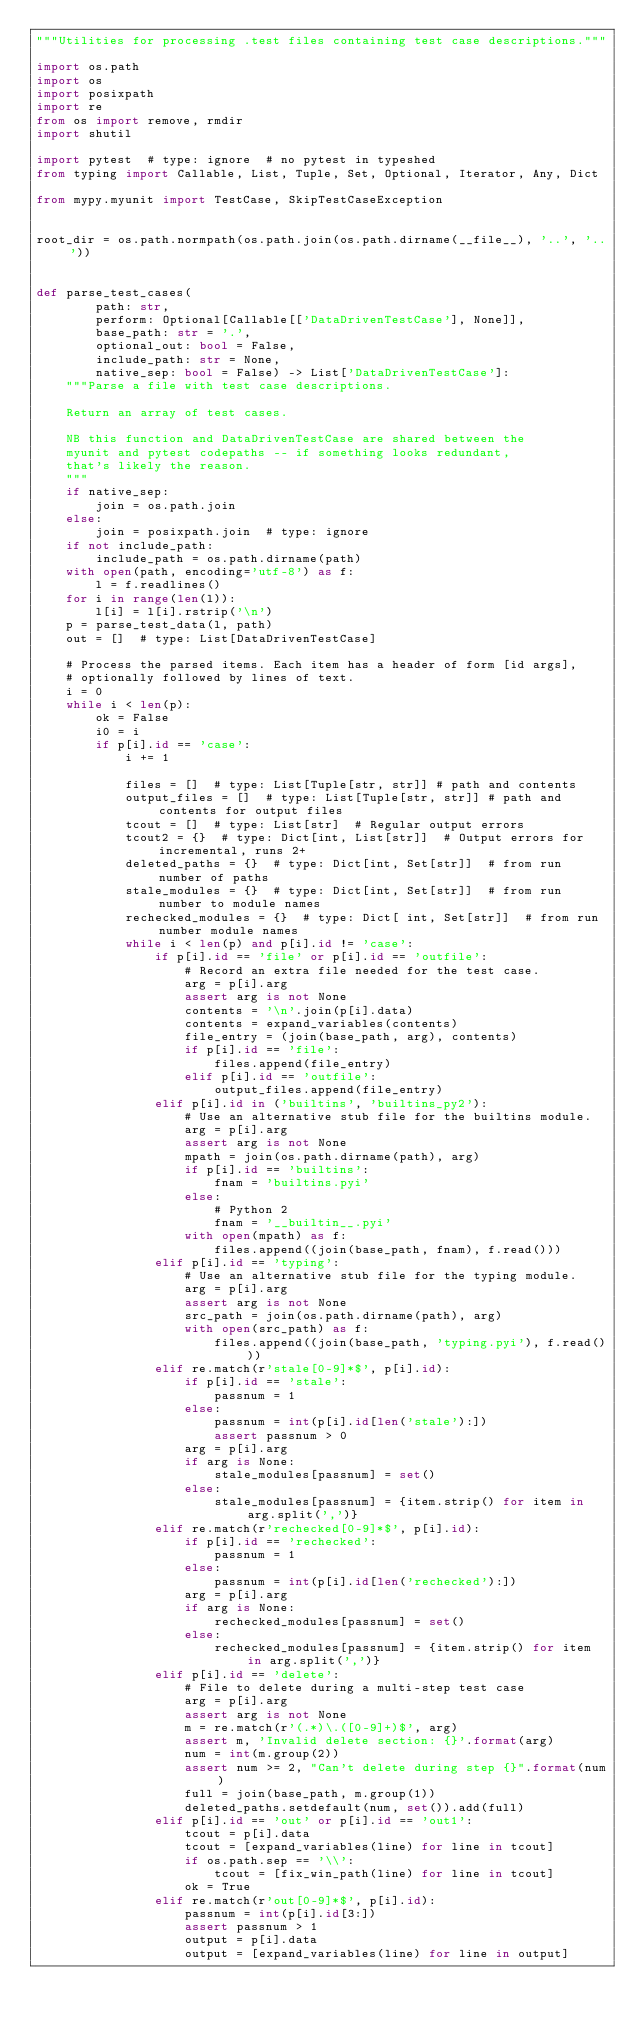Convert code to text. <code><loc_0><loc_0><loc_500><loc_500><_Python_>"""Utilities for processing .test files containing test case descriptions."""

import os.path
import os
import posixpath
import re
from os import remove, rmdir
import shutil

import pytest  # type: ignore  # no pytest in typeshed
from typing import Callable, List, Tuple, Set, Optional, Iterator, Any, Dict

from mypy.myunit import TestCase, SkipTestCaseException


root_dir = os.path.normpath(os.path.join(os.path.dirname(__file__), '..', '..'))


def parse_test_cases(
        path: str,
        perform: Optional[Callable[['DataDrivenTestCase'], None]],
        base_path: str = '.',
        optional_out: bool = False,
        include_path: str = None,
        native_sep: bool = False) -> List['DataDrivenTestCase']:
    """Parse a file with test case descriptions.

    Return an array of test cases.

    NB this function and DataDrivenTestCase are shared between the
    myunit and pytest codepaths -- if something looks redundant,
    that's likely the reason.
    """
    if native_sep:
        join = os.path.join
    else:
        join = posixpath.join  # type: ignore
    if not include_path:
        include_path = os.path.dirname(path)
    with open(path, encoding='utf-8') as f:
        l = f.readlines()
    for i in range(len(l)):
        l[i] = l[i].rstrip('\n')
    p = parse_test_data(l, path)
    out = []  # type: List[DataDrivenTestCase]

    # Process the parsed items. Each item has a header of form [id args],
    # optionally followed by lines of text.
    i = 0
    while i < len(p):
        ok = False
        i0 = i
        if p[i].id == 'case':
            i += 1

            files = []  # type: List[Tuple[str, str]] # path and contents
            output_files = []  # type: List[Tuple[str, str]] # path and contents for output files
            tcout = []  # type: List[str]  # Regular output errors
            tcout2 = {}  # type: Dict[int, List[str]]  # Output errors for incremental, runs 2+
            deleted_paths = {}  # type: Dict[int, Set[str]]  # from run number of paths
            stale_modules = {}  # type: Dict[int, Set[str]]  # from run number to module names
            rechecked_modules = {}  # type: Dict[ int, Set[str]]  # from run number module names
            while i < len(p) and p[i].id != 'case':
                if p[i].id == 'file' or p[i].id == 'outfile':
                    # Record an extra file needed for the test case.
                    arg = p[i].arg
                    assert arg is not None
                    contents = '\n'.join(p[i].data)
                    contents = expand_variables(contents)
                    file_entry = (join(base_path, arg), contents)
                    if p[i].id == 'file':
                        files.append(file_entry)
                    elif p[i].id == 'outfile':
                        output_files.append(file_entry)
                elif p[i].id in ('builtins', 'builtins_py2'):
                    # Use an alternative stub file for the builtins module.
                    arg = p[i].arg
                    assert arg is not None
                    mpath = join(os.path.dirname(path), arg)
                    if p[i].id == 'builtins':
                        fnam = 'builtins.pyi'
                    else:
                        # Python 2
                        fnam = '__builtin__.pyi'
                    with open(mpath) as f:
                        files.append((join(base_path, fnam), f.read()))
                elif p[i].id == 'typing':
                    # Use an alternative stub file for the typing module.
                    arg = p[i].arg
                    assert arg is not None
                    src_path = join(os.path.dirname(path), arg)
                    with open(src_path) as f:
                        files.append((join(base_path, 'typing.pyi'), f.read()))
                elif re.match(r'stale[0-9]*$', p[i].id):
                    if p[i].id == 'stale':
                        passnum = 1
                    else:
                        passnum = int(p[i].id[len('stale'):])
                        assert passnum > 0
                    arg = p[i].arg
                    if arg is None:
                        stale_modules[passnum] = set()
                    else:
                        stale_modules[passnum] = {item.strip() for item in arg.split(',')}
                elif re.match(r'rechecked[0-9]*$', p[i].id):
                    if p[i].id == 'rechecked':
                        passnum = 1
                    else:
                        passnum = int(p[i].id[len('rechecked'):])
                    arg = p[i].arg
                    if arg is None:
                        rechecked_modules[passnum] = set()
                    else:
                        rechecked_modules[passnum] = {item.strip() for item in arg.split(',')}
                elif p[i].id == 'delete':
                    # File to delete during a multi-step test case
                    arg = p[i].arg
                    assert arg is not None
                    m = re.match(r'(.*)\.([0-9]+)$', arg)
                    assert m, 'Invalid delete section: {}'.format(arg)
                    num = int(m.group(2))
                    assert num >= 2, "Can't delete during step {}".format(num)
                    full = join(base_path, m.group(1))
                    deleted_paths.setdefault(num, set()).add(full)
                elif p[i].id == 'out' or p[i].id == 'out1':
                    tcout = p[i].data
                    tcout = [expand_variables(line) for line in tcout]
                    if os.path.sep == '\\':
                        tcout = [fix_win_path(line) for line in tcout]
                    ok = True
                elif re.match(r'out[0-9]*$', p[i].id):
                    passnum = int(p[i].id[3:])
                    assert passnum > 1
                    output = p[i].data
                    output = [expand_variables(line) for line in output]</code> 